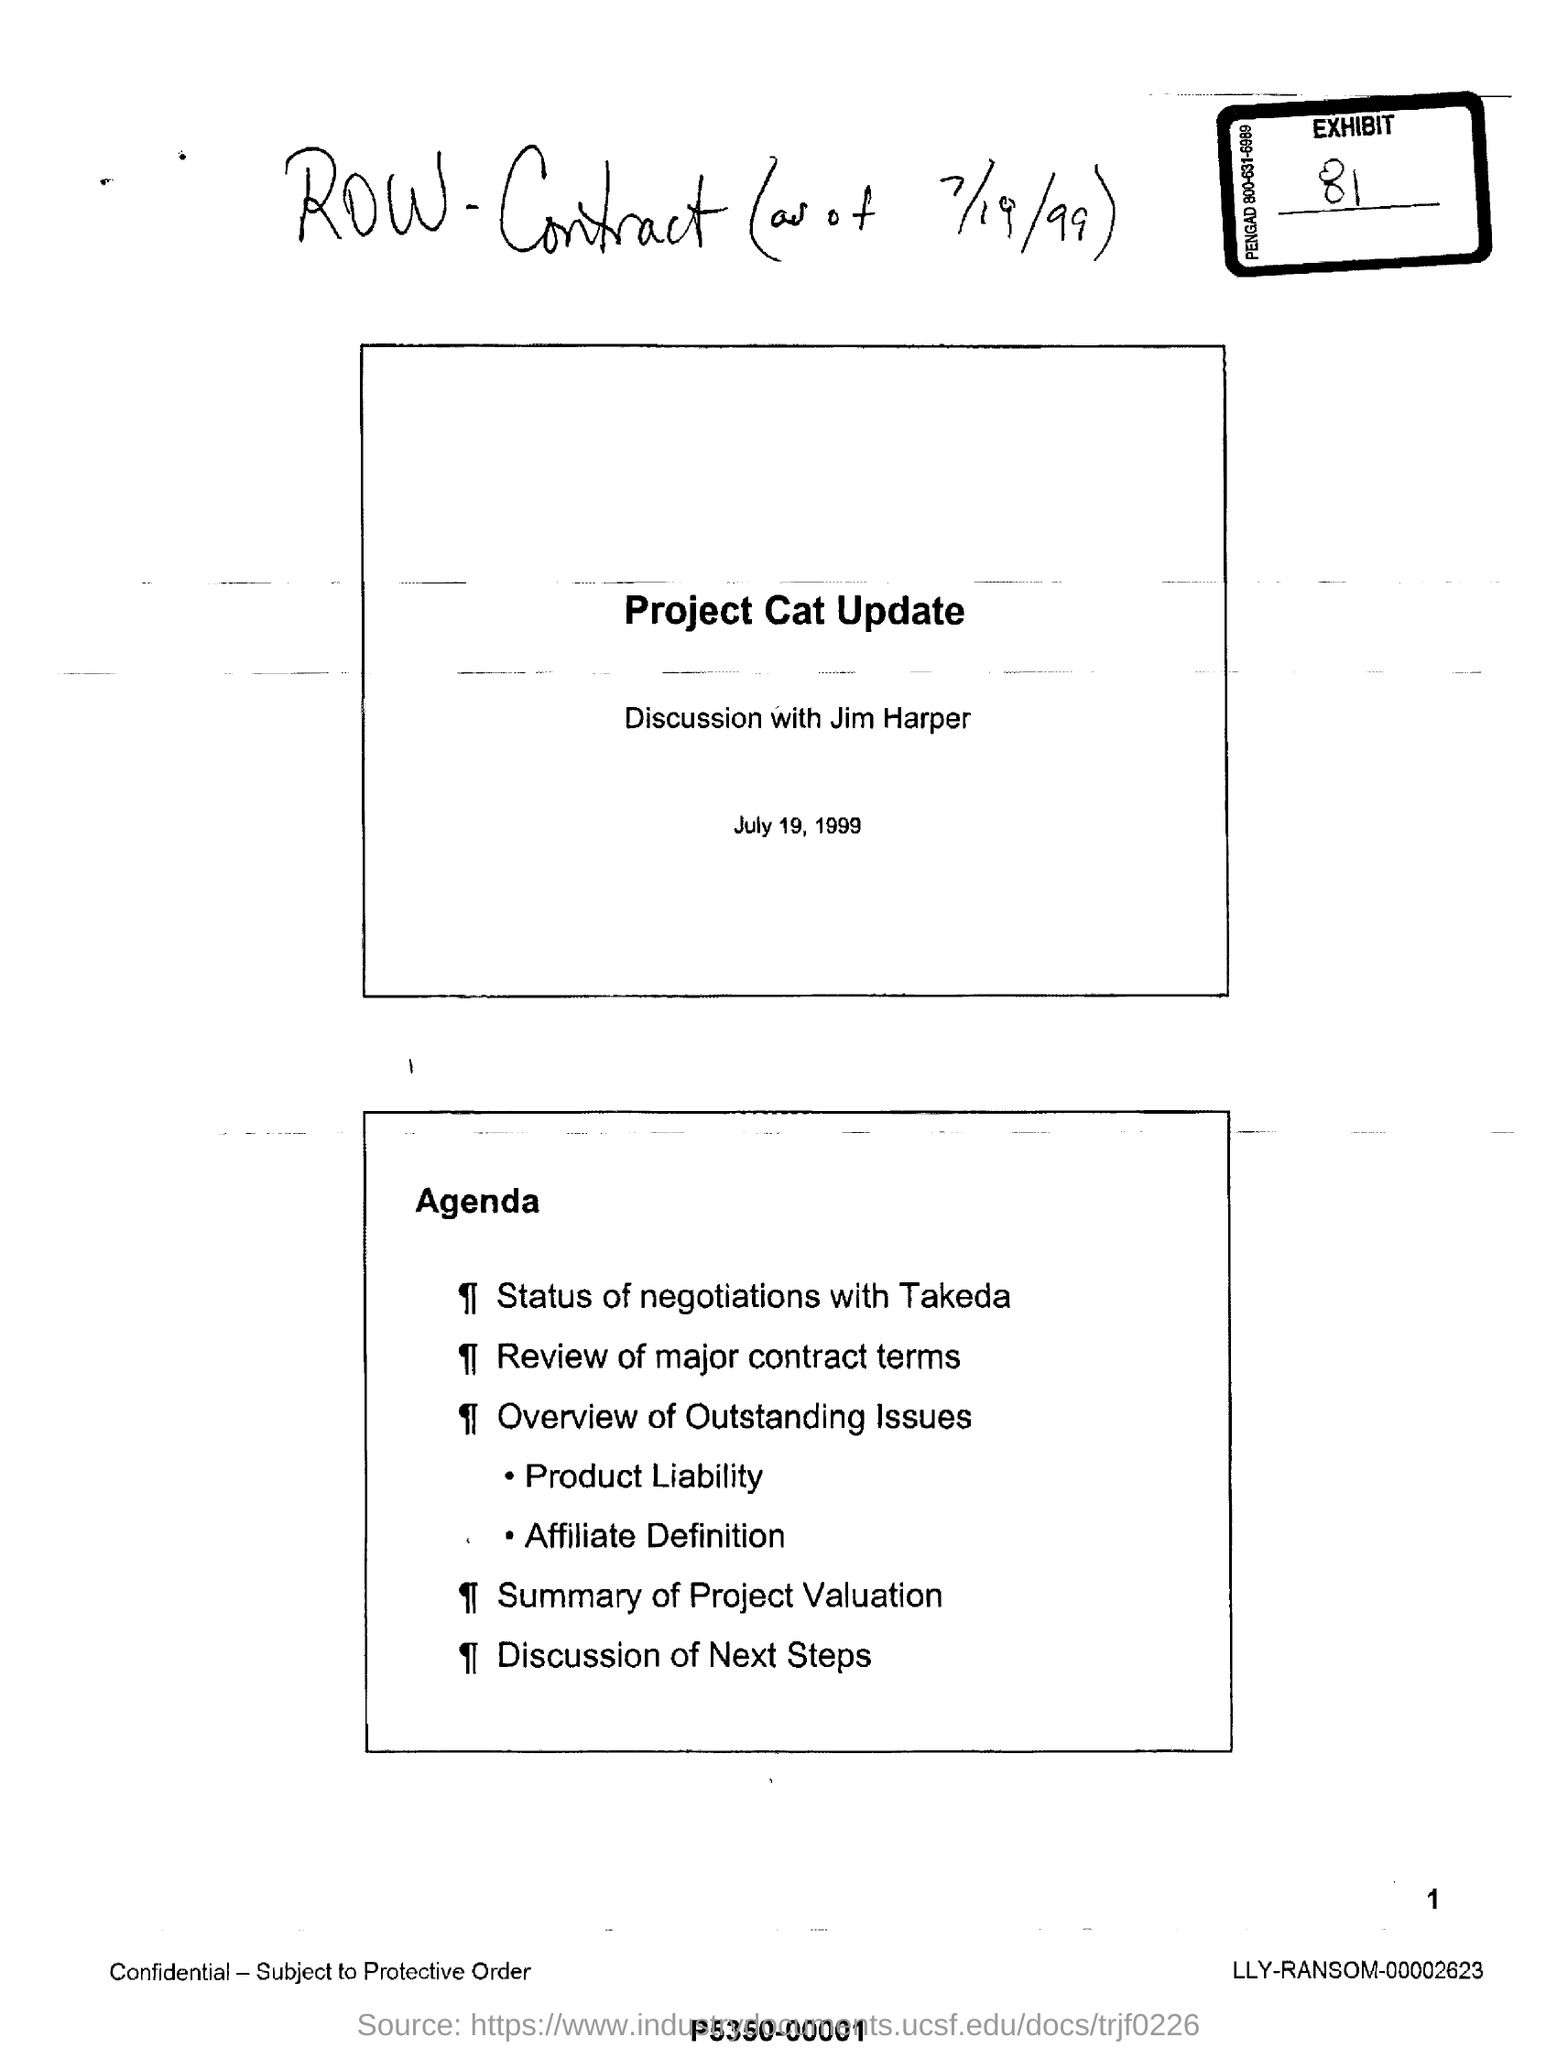Give some essential details in this illustration. The discussion is being held with Jim Harper. The date mentioned is July 19, 1999. 